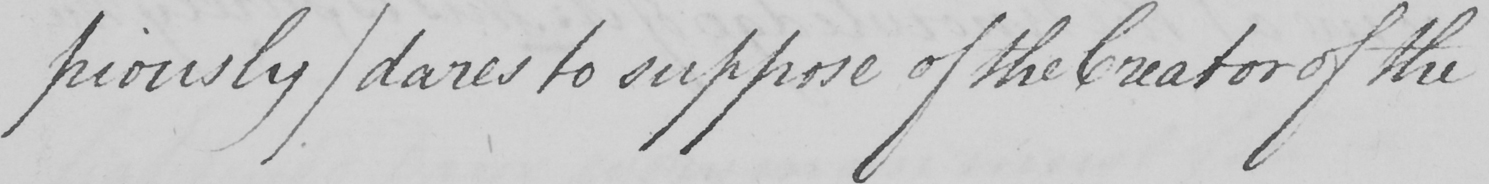Please provide the text content of this handwritten line. piously )  dares to suppose of the Creator of the 